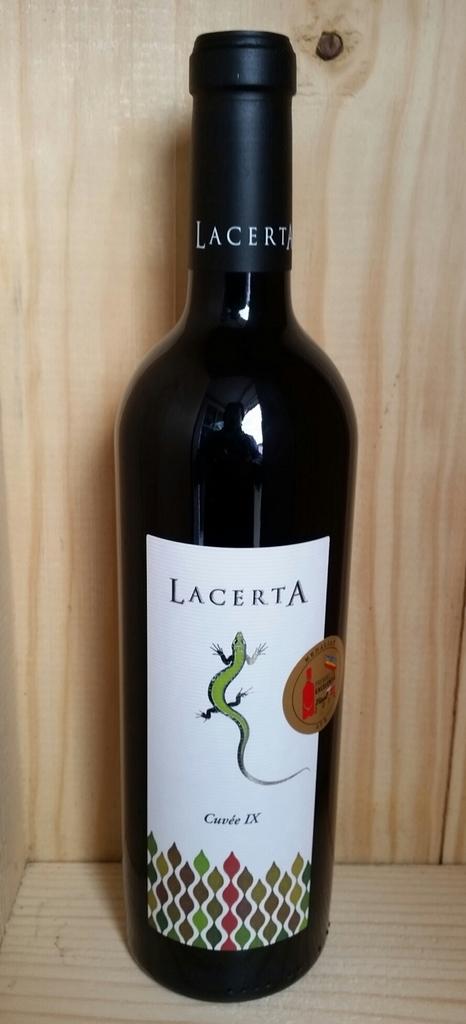What number of wine is the lacerta cuvee?
Provide a short and direct response. Ix. 